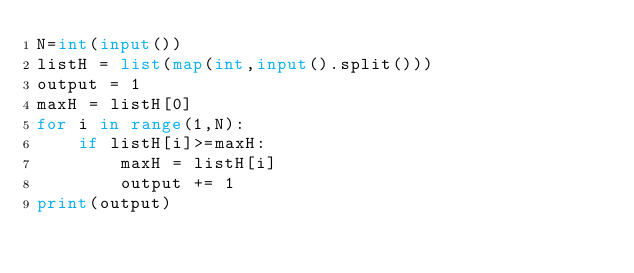Convert code to text. <code><loc_0><loc_0><loc_500><loc_500><_Python_>N=int(input())
listH = list(map(int,input().split()))
output = 1
maxH = listH[0]
for i in range(1,N):
    if listH[i]>=maxH:
        maxH = listH[i]
        output += 1
print(output)</code> 